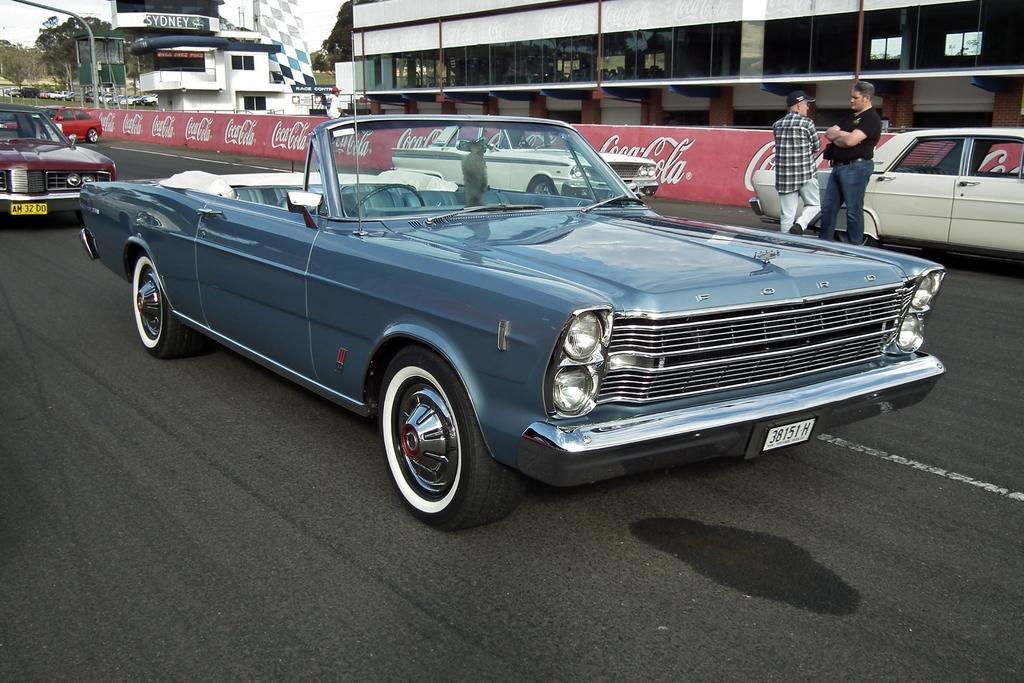How would you summarize this image in a sentence or two? In this image we can see persons standing on the road, motor vehicles, advertisement boards, buildings, trees and sky. 